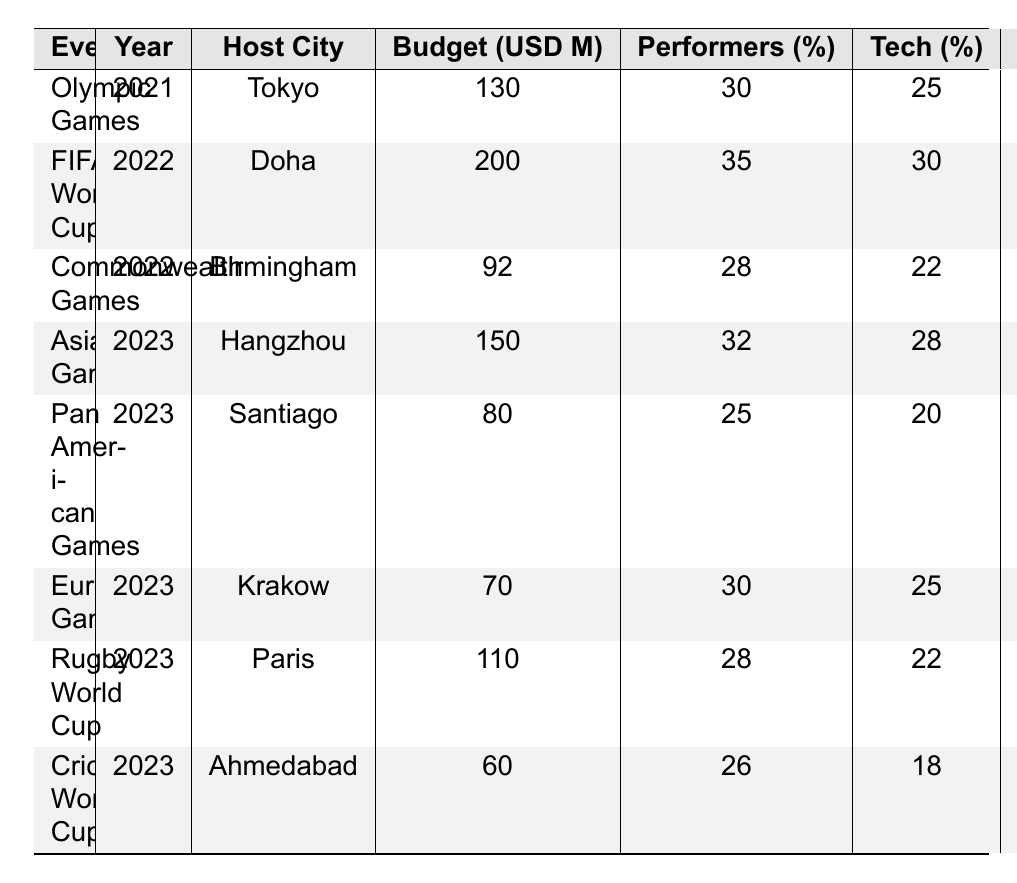What is the total budget for the FIFA World Cup? Referring to the table, the total budget for the FIFA World Cup is listed under the "Total Budget (USD M)" column for the year 2022, which shows a value of 200 million USD.
Answer: 200 million USD Which event has the highest percentage allocated for performers? Looking at the "Performers (%)" column, the FIFA World Cup has the highest allocation at 35%.
Answer: 35% What is the percentage allocated for logistics in the Asian Games? The "Logistics (%)" column for the Asian Games in 2023 shows a value of 6%.
Answer: 6% Which event has the lowest total budget? The "Total Budget (USD M)" shows that the Cricket World Cup has the lowest value of 60 million USD.
Answer: 60 million USD Calculate the average percentage allocation for technology across all events. The percentages for technology are 25, 30, 22, 28, 20, 25, 22, and 18. Adding them gives 200. There are 8 events, so the average is 200/8 = 25%.
Answer: 25% Is the percentage allocated for set design in the Rugby World Cup greater than in the FIFA World Cup? The "Set Design (%)" for the Rugby World Cup is 20%, and for the FIFA World Cup it's 15%. Since 20% is greater than 15%, the statement is true.
Answer: Yes Which event allocated the most for costumes, and what is that percentage? The "Costumes (%)" column shows the Rugby World Cup allocated 14%, while the Cricket World Cup allocated 16%. Thus, the Cricket World Cup allocated the most at 16%.
Answer: Cricket World Cup, 16% What is the difference in total budget between the Olympic Games and the Pan American Games? The Olympic Games has a budget of 130 million USD, and the Pan American Games has 80 million USD. The difference is 130 - 80 = 50 million USD.
Answer: 50 million USD Which events have a higher technology allocation than the Commonwealth Games? The Commonwealth Games allocated 22% for technology. The events with higher allocations are the FIFA World Cup (30%), Asian Games (28%), and European Games (25%).
Answer: FIFA World Cup, Asian Games, European Games Calculate the total budget allocated of all events hosted in 2023. The events in 2023 are the Asian Games (150 million), Pan American Games (80 million), European Games (70 million), Rugby World Cup (110 million), and Cricket World Cup (60 million). Adding them gives 150 + 80 + 70 + 110 + 60 = 470 million USD.
Answer: 470 million USD 